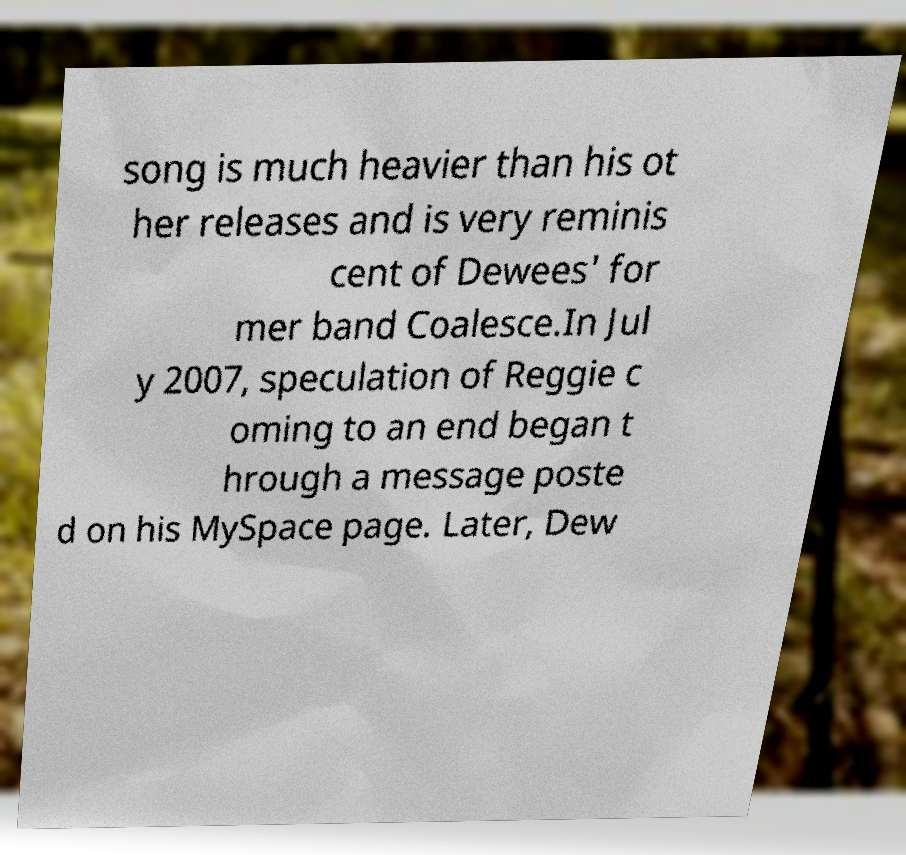Please read and relay the text visible in this image. What does it say? song is much heavier than his ot her releases and is very reminis cent of Dewees' for mer band Coalesce.In Jul y 2007, speculation of Reggie c oming to an end began t hrough a message poste d on his MySpace page. Later, Dew 